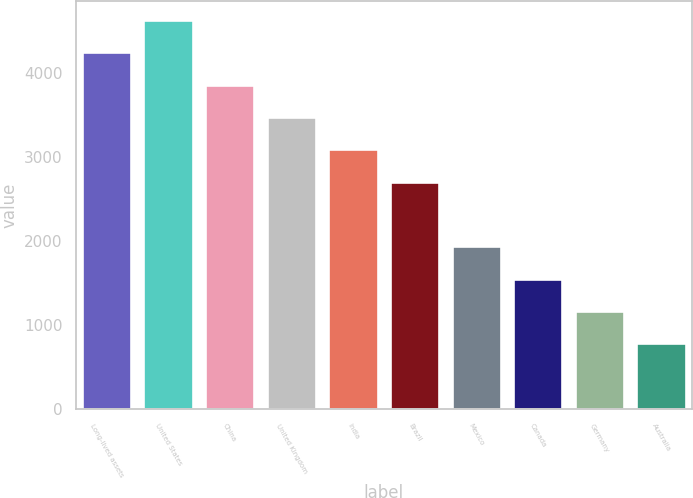<chart> <loc_0><loc_0><loc_500><loc_500><bar_chart><fcel>Long-lived assets<fcel>United States<fcel>China<fcel>United Kingdom<fcel>India<fcel>Brazil<fcel>Mexico<fcel>Canada<fcel>Germany<fcel>Australia<nl><fcel>4246.3<fcel>4630.6<fcel>3862<fcel>3477.7<fcel>3093.4<fcel>2709.1<fcel>1940.5<fcel>1556.2<fcel>1171.9<fcel>787.6<nl></chart> 